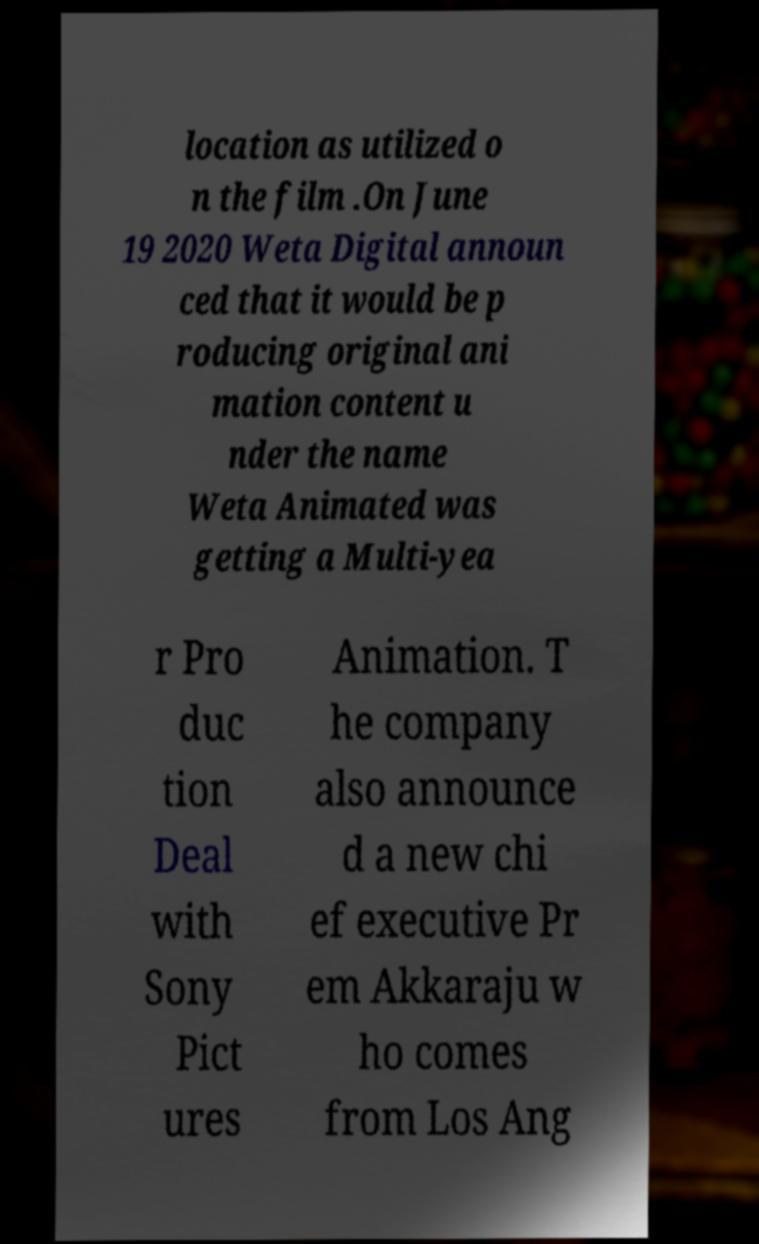Please read and relay the text visible in this image. What does it say? location as utilized o n the film .On June 19 2020 Weta Digital announ ced that it would be p roducing original ani mation content u nder the name Weta Animated was getting a Multi-yea r Pro duc tion Deal with Sony Pict ures Animation. T he company also announce d a new chi ef executive Pr em Akkaraju w ho comes from Los Ang 